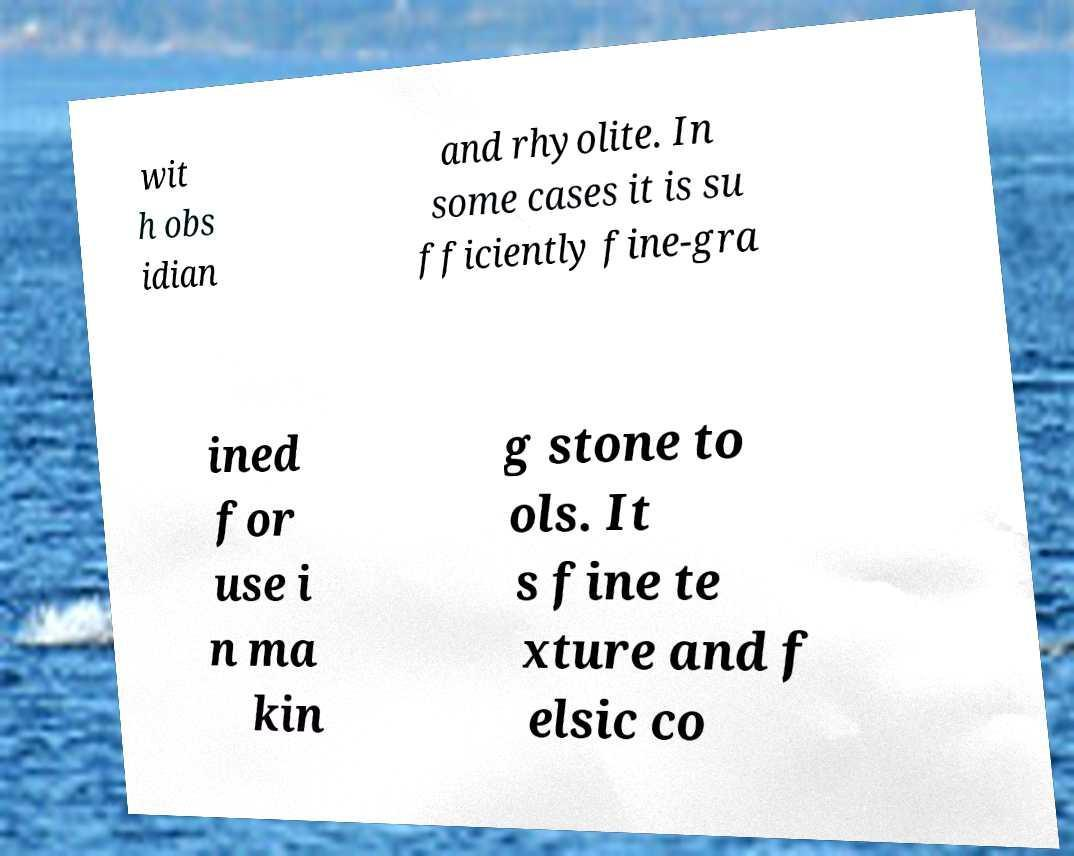Can you read and provide the text displayed in the image?This photo seems to have some interesting text. Can you extract and type it out for me? wit h obs idian and rhyolite. In some cases it is su fficiently fine-gra ined for use i n ma kin g stone to ols. It s fine te xture and f elsic co 